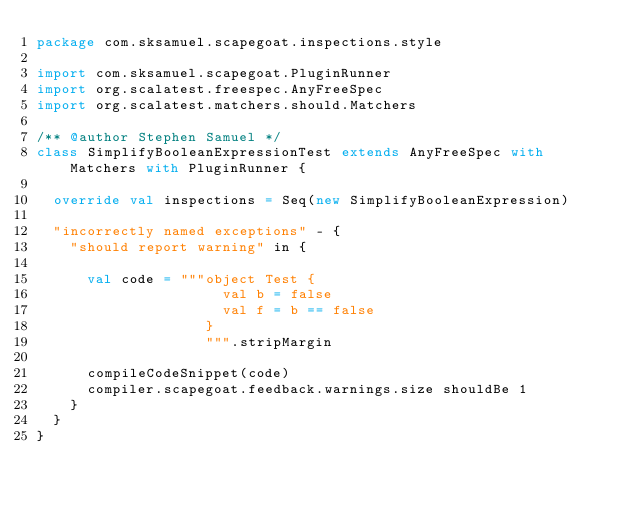<code> <loc_0><loc_0><loc_500><loc_500><_Scala_>package com.sksamuel.scapegoat.inspections.style

import com.sksamuel.scapegoat.PluginRunner
import org.scalatest.freespec.AnyFreeSpec
import org.scalatest.matchers.should.Matchers

/** @author Stephen Samuel */
class SimplifyBooleanExpressionTest extends AnyFreeSpec with Matchers with PluginRunner {

  override val inspections = Seq(new SimplifyBooleanExpression)

  "incorrectly named exceptions" - {
    "should report warning" in {

      val code = """object Test {
                      val b = false
                      val f = b == false
                    }
                    """.stripMargin

      compileCodeSnippet(code)
      compiler.scapegoat.feedback.warnings.size shouldBe 1
    }
  }
}
</code> 